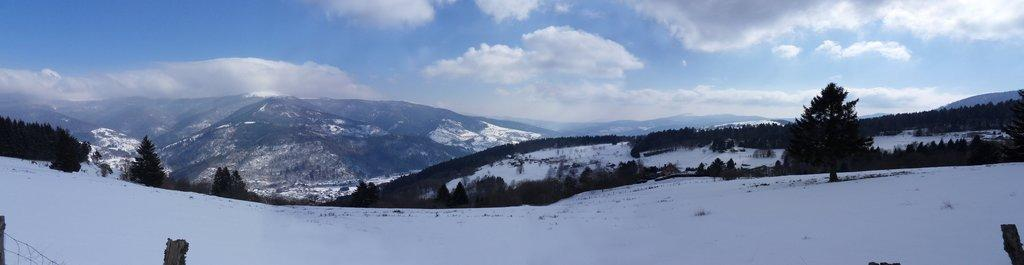What type of terrain is visible in the image? There is land visible in the image. What type of vegetation can be seen in the image? Trees are present in the image. What geographical feature is covered with snow in the image? Mountains covered with snow are visible in the image. What type of barrier is present in the image? There is an iron fence in the image. What material is present in the image? Wood is present in the image. What color is the sky in the image? The sky is blue in the image. How many pets are visible in the image? There are no pets visible in the image. What type of tree is growing on the foot of the mountain in the image? There is no tree growing on the foot of the mountain in the image, and there is no mention of a foot in the provided facts. 